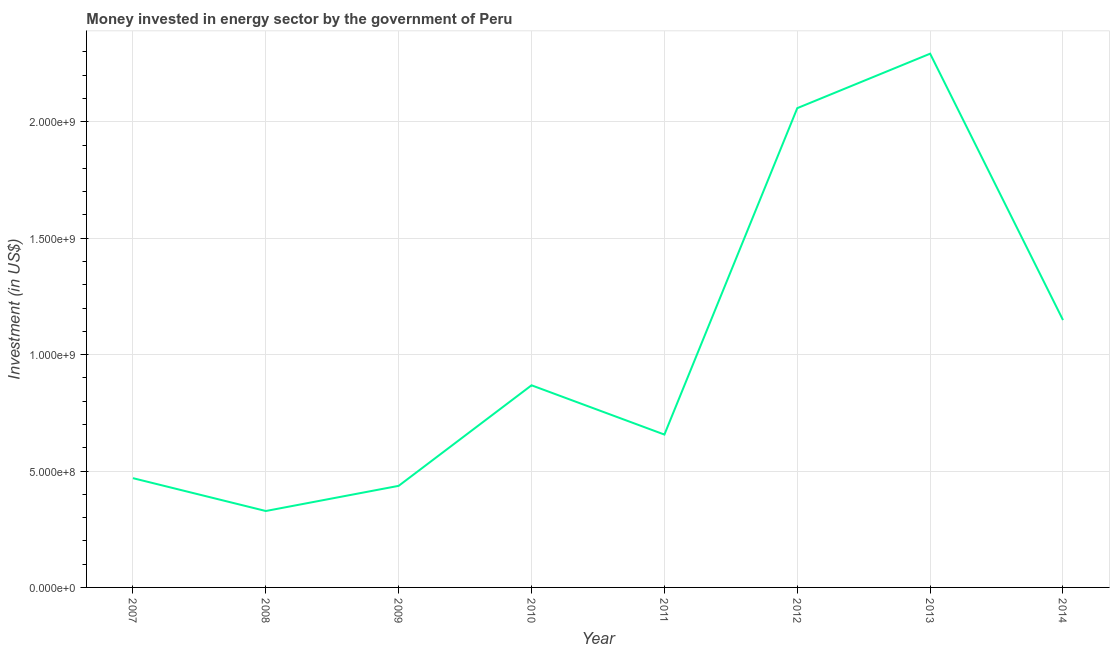What is the investment in energy in 2007?
Provide a short and direct response. 4.69e+08. Across all years, what is the maximum investment in energy?
Offer a terse response. 2.29e+09. Across all years, what is the minimum investment in energy?
Make the answer very short. 3.28e+08. What is the sum of the investment in energy?
Offer a very short reply. 8.26e+09. What is the difference between the investment in energy in 2009 and 2014?
Provide a short and direct response. -7.12e+08. What is the average investment in energy per year?
Give a very brief answer. 1.03e+09. What is the median investment in energy?
Keep it short and to the point. 7.62e+08. What is the ratio of the investment in energy in 2008 to that in 2010?
Your answer should be very brief. 0.38. Is the difference between the investment in energy in 2008 and 2011 greater than the difference between any two years?
Keep it short and to the point. No. What is the difference between the highest and the second highest investment in energy?
Your response must be concise. 2.34e+08. Is the sum of the investment in energy in 2009 and 2013 greater than the maximum investment in energy across all years?
Your answer should be compact. Yes. What is the difference between the highest and the lowest investment in energy?
Offer a terse response. 1.96e+09. Does the investment in energy monotonically increase over the years?
Your answer should be very brief. No. How many years are there in the graph?
Ensure brevity in your answer.  8. What is the difference between two consecutive major ticks on the Y-axis?
Offer a very short reply. 5.00e+08. Are the values on the major ticks of Y-axis written in scientific E-notation?
Ensure brevity in your answer.  Yes. Does the graph contain any zero values?
Provide a short and direct response. No. Does the graph contain grids?
Offer a very short reply. Yes. What is the title of the graph?
Offer a very short reply. Money invested in energy sector by the government of Peru. What is the label or title of the Y-axis?
Offer a terse response. Investment (in US$). What is the Investment (in US$) in 2007?
Offer a very short reply. 4.69e+08. What is the Investment (in US$) in 2008?
Give a very brief answer. 3.28e+08. What is the Investment (in US$) of 2009?
Give a very brief answer. 4.36e+08. What is the Investment (in US$) in 2010?
Your response must be concise. 8.68e+08. What is the Investment (in US$) of 2011?
Give a very brief answer. 6.56e+08. What is the Investment (in US$) in 2012?
Your answer should be compact. 2.06e+09. What is the Investment (in US$) of 2013?
Your answer should be compact. 2.29e+09. What is the Investment (in US$) of 2014?
Your answer should be very brief. 1.15e+09. What is the difference between the Investment (in US$) in 2007 and 2008?
Provide a succinct answer. 1.41e+08. What is the difference between the Investment (in US$) in 2007 and 2009?
Make the answer very short. 3.30e+07. What is the difference between the Investment (in US$) in 2007 and 2010?
Your response must be concise. -3.99e+08. What is the difference between the Investment (in US$) in 2007 and 2011?
Provide a succinct answer. -1.87e+08. What is the difference between the Investment (in US$) in 2007 and 2012?
Your response must be concise. -1.59e+09. What is the difference between the Investment (in US$) in 2007 and 2013?
Provide a short and direct response. -1.82e+09. What is the difference between the Investment (in US$) in 2007 and 2014?
Keep it short and to the point. -6.79e+08. What is the difference between the Investment (in US$) in 2008 and 2009?
Your answer should be very brief. -1.08e+08. What is the difference between the Investment (in US$) in 2008 and 2010?
Give a very brief answer. -5.40e+08. What is the difference between the Investment (in US$) in 2008 and 2011?
Ensure brevity in your answer.  -3.28e+08. What is the difference between the Investment (in US$) in 2008 and 2012?
Keep it short and to the point. -1.73e+09. What is the difference between the Investment (in US$) in 2008 and 2013?
Give a very brief answer. -1.96e+09. What is the difference between the Investment (in US$) in 2008 and 2014?
Your answer should be very brief. -8.20e+08. What is the difference between the Investment (in US$) in 2009 and 2010?
Keep it short and to the point. -4.32e+08. What is the difference between the Investment (in US$) in 2009 and 2011?
Provide a short and direct response. -2.20e+08. What is the difference between the Investment (in US$) in 2009 and 2012?
Keep it short and to the point. -1.62e+09. What is the difference between the Investment (in US$) in 2009 and 2013?
Offer a terse response. -1.86e+09. What is the difference between the Investment (in US$) in 2009 and 2014?
Give a very brief answer. -7.12e+08. What is the difference between the Investment (in US$) in 2010 and 2011?
Ensure brevity in your answer.  2.12e+08. What is the difference between the Investment (in US$) in 2010 and 2012?
Ensure brevity in your answer.  -1.19e+09. What is the difference between the Investment (in US$) in 2010 and 2013?
Make the answer very short. -1.42e+09. What is the difference between the Investment (in US$) in 2010 and 2014?
Offer a very short reply. -2.80e+08. What is the difference between the Investment (in US$) in 2011 and 2012?
Your answer should be compact. -1.40e+09. What is the difference between the Investment (in US$) in 2011 and 2013?
Give a very brief answer. -1.64e+09. What is the difference between the Investment (in US$) in 2011 and 2014?
Offer a very short reply. -4.92e+08. What is the difference between the Investment (in US$) in 2012 and 2013?
Your answer should be compact. -2.34e+08. What is the difference between the Investment (in US$) in 2012 and 2014?
Keep it short and to the point. 9.10e+08. What is the difference between the Investment (in US$) in 2013 and 2014?
Your answer should be very brief. 1.14e+09. What is the ratio of the Investment (in US$) in 2007 to that in 2008?
Your answer should be very brief. 1.43. What is the ratio of the Investment (in US$) in 2007 to that in 2009?
Offer a very short reply. 1.08. What is the ratio of the Investment (in US$) in 2007 to that in 2010?
Your response must be concise. 0.54. What is the ratio of the Investment (in US$) in 2007 to that in 2011?
Your answer should be compact. 0.71. What is the ratio of the Investment (in US$) in 2007 to that in 2012?
Offer a terse response. 0.23. What is the ratio of the Investment (in US$) in 2007 to that in 2013?
Provide a short and direct response. 0.2. What is the ratio of the Investment (in US$) in 2007 to that in 2014?
Your response must be concise. 0.41. What is the ratio of the Investment (in US$) in 2008 to that in 2009?
Offer a very short reply. 0.75. What is the ratio of the Investment (in US$) in 2008 to that in 2010?
Provide a succinct answer. 0.38. What is the ratio of the Investment (in US$) in 2008 to that in 2012?
Make the answer very short. 0.16. What is the ratio of the Investment (in US$) in 2008 to that in 2013?
Give a very brief answer. 0.14. What is the ratio of the Investment (in US$) in 2008 to that in 2014?
Your answer should be compact. 0.29. What is the ratio of the Investment (in US$) in 2009 to that in 2010?
Your answer should be compact. 0.5. What is the ratio of the Investment (in US$) in 2009 to that in 2011?
Your answer should be very brief. 0.67. What is the ratio of the Investment (in US$) in 2009 to that in 2012?
Provide a succinct answer. 0.21. What is the ratio of the Investment (in US$) in 2009 to that in 2013?
Your answer should be compact. 0.19. What is the ratio of the Investment (in US$) in 2009 to that in 2014?
Your answer should be very brief. 0.38. What is the ratio of the Investment (in US$) in 2010 to that in 2011?
Offer a very short reply. 1.32. What is the ratio of the Investment (in US$) in 2010 to that in 2012?
Ensure brevity in your answer.  0.42. What is the ratio of the Investment (in US$) in 2010 to that in 2013?
Your answer should be compact. 0.38. What is the ratio of the Investment (in US$) in 2010 to that in 2014?
Give a very brief answer. 0.76. What is the ratio of the Investment (in US$) in 2011 to that in 2012?
Your response must be concise. 0.32. What is the ratio of the Investment (in US$) in 2011 to that in 2013?
Ensure brevity in your answer.  0.29. What is the ratio of the Investment (in US$) in 2011 to that in 2014?
Offer a very short reply. 0.57. What is the ratio of the Investment (in US$) in 2012 to that in 2013?
Offer a very short reply. 0.9. What is the ratio of the Investment (in US$) in 2012 to that in 2014?
Provide a succinct answer. 1.79. What is the ratio of the Investment (in US$) in 2013 to that in 2014?
Make the answer very short. 2. 